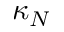<formula> <loc_0><loc_0><loc_500><loc_500>\kappa _ { N }</formula> 